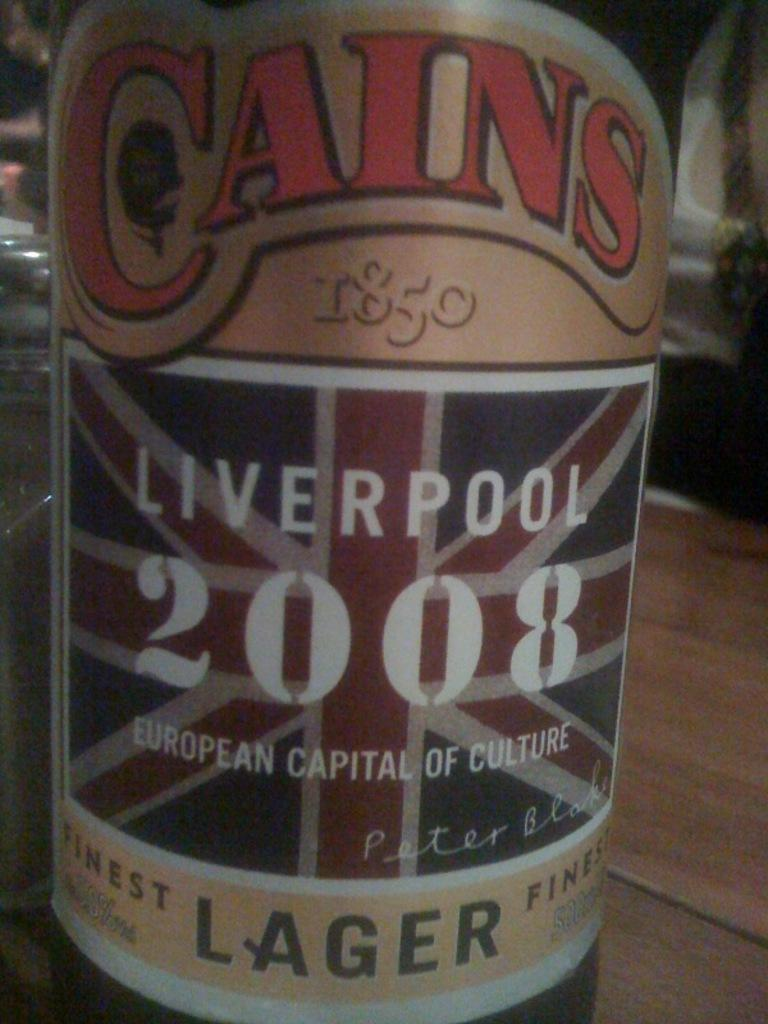<image>
Describe the image concisely. A bottle of Cains Lager sits on the table 